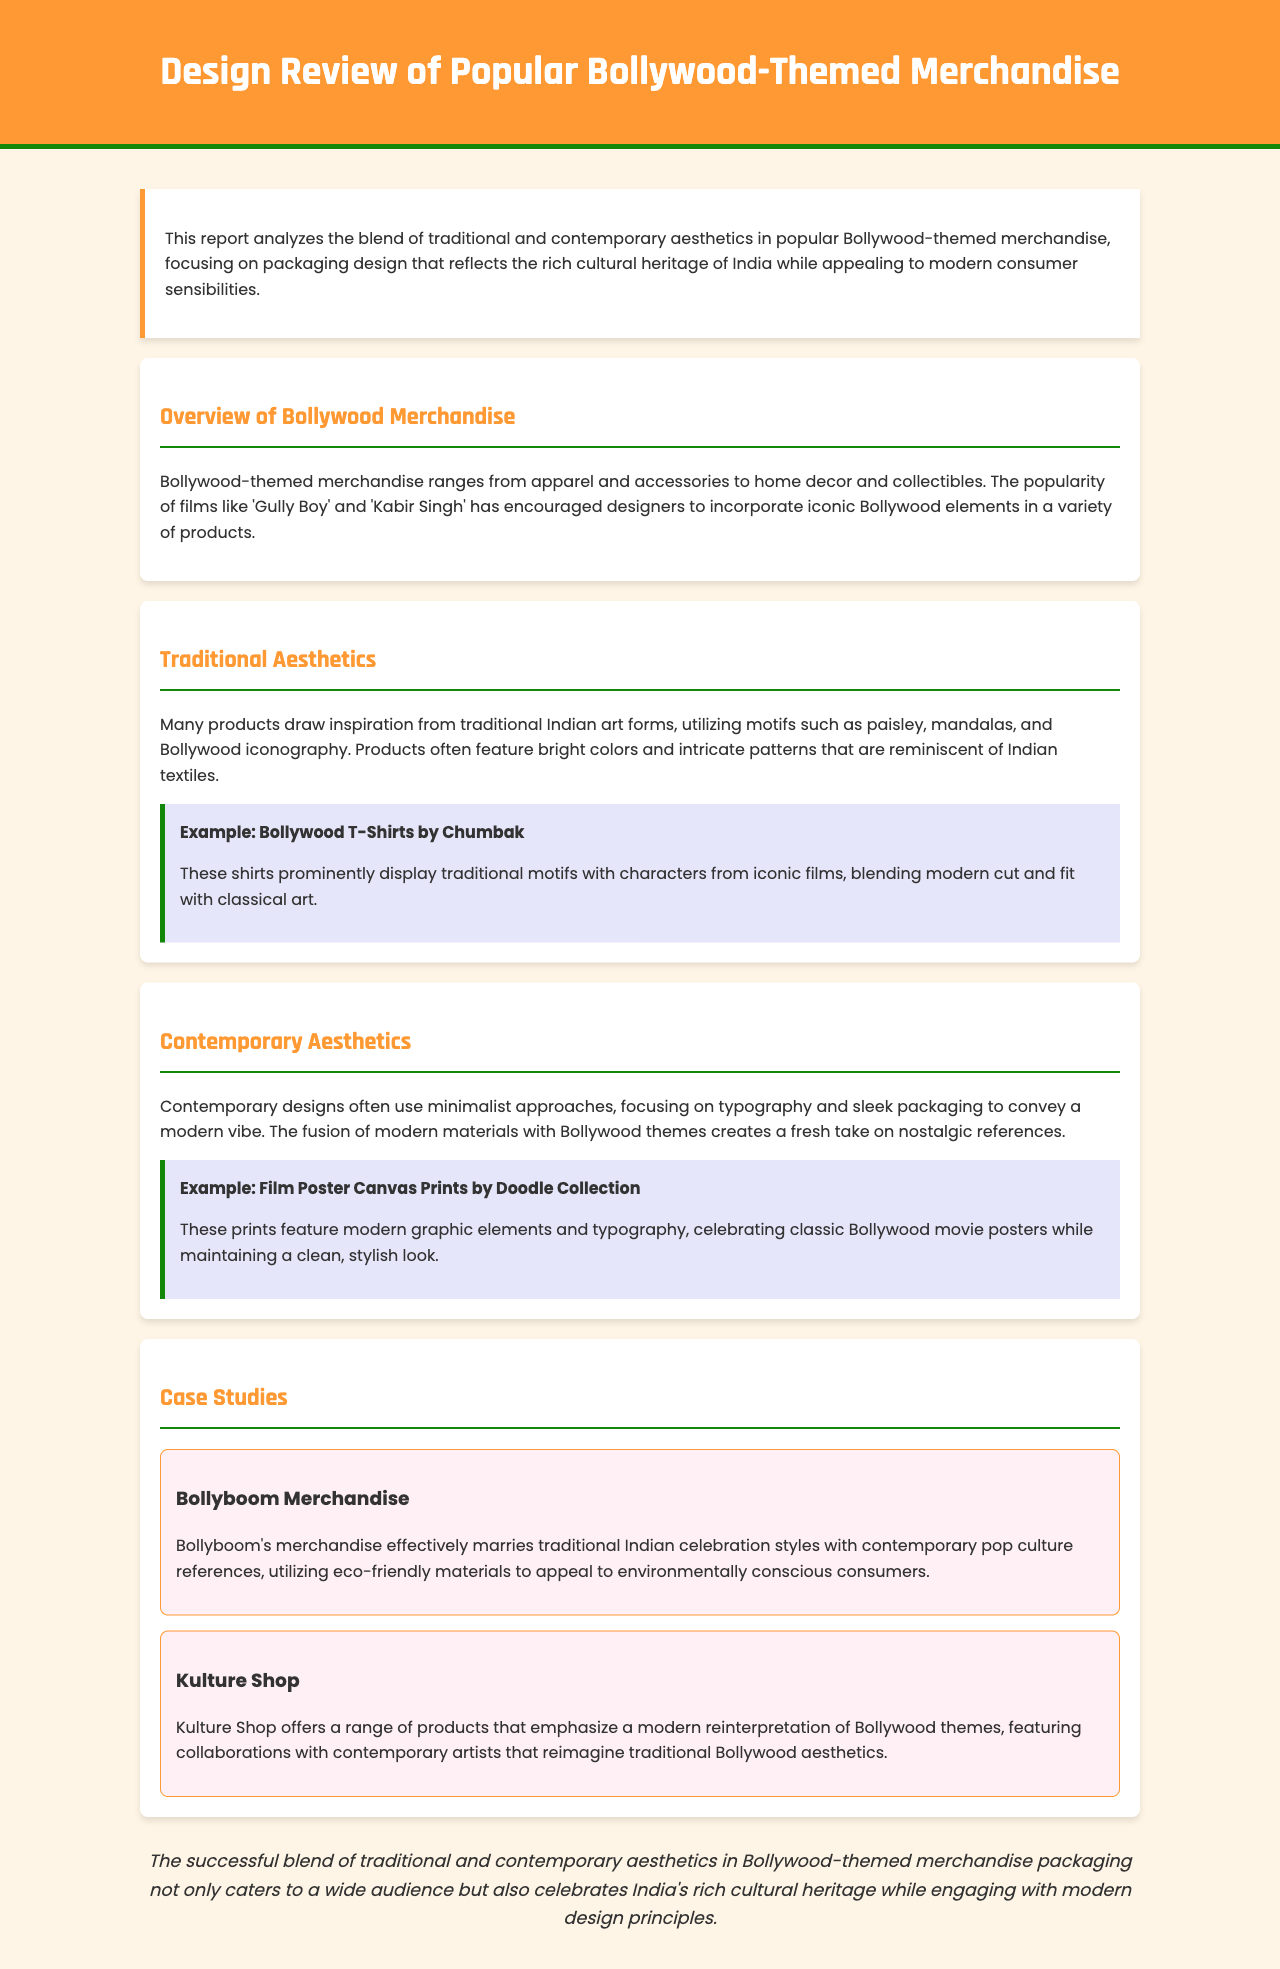What is the title of the report? The title of the report is stated in the header section of the document.
Answer: Design Review of Popular Bollywood-Themed Merchandise What type of products are discussed in the overview? The overview mentions categories of products related to Bollywood-themed merchandise.
Answer: Apparel and accessories Which company is mentioned for Bollywood T-Shirts? The specific company noted for their Bollywood T-Shirts is presented in the traditional aesthetics section.
Answer: Chumbak What art forms inspire traditional aesthetics? The document lists specific motifs that are foundational in traditional aesthetics.
Answer: Paisley, mandalas What materials does Bollyboom use for its merchandise? The report highlights the material choices made by Bollyboom in the case study section.
Answer: Eco-friendly materials How does Kulture Shop reinterpret Bollywood themes? The document mentions Kulture Shop's approach to Bollywood themes in their case study.
Answer: Collaborations with contemporary artists What common design feature is noted in contemporary aesthetics? It highlights a specific approach that characterizes contemporary designs.
Answer: Minimalist approaches What is the conclusion about the blend of aesthetics? The conclusion summarizes the overall impact of the traditional and contemporary blend in merchandise packaging.
Answer: Celebrates India's rich cultural heritage 